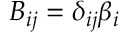<formula> <loc_0><loc_0><loc_500><loc_500>B _ { i j } = \delta _ { i j } \beta _ { i }</formula> 